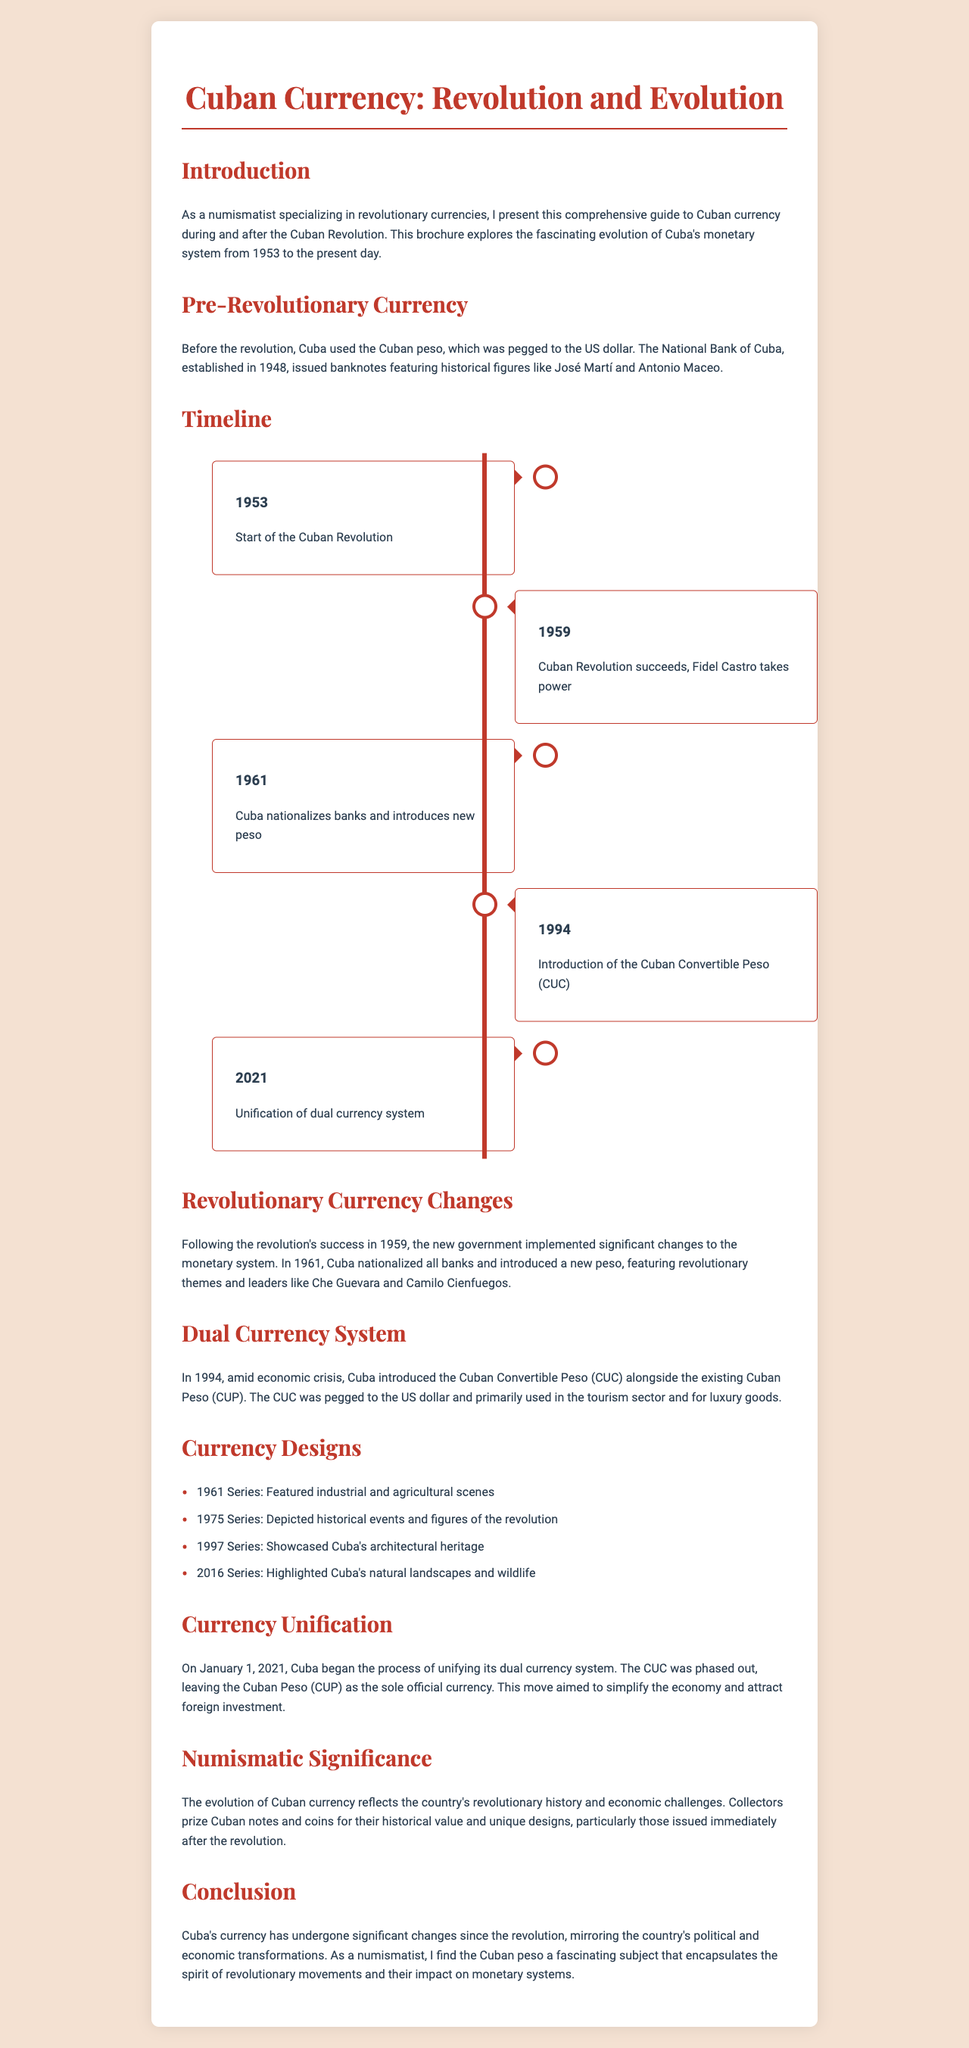What year did the Cuban Revolution begin? The brochure states that the Cuban Revolution started in 1953.
Answer: 1953 What is the main currency introduced in 1961? The document mentions that in 1961, Cuba nationalized banks and introduced a new peso.
Answer: New peso What significant event occurred in 2021 regarding Cuban currency? The brochure highlights that in 2021, Cuba unified its dual currency system.
Answer: Currency unification Which notable figure is featured on banknotes from the pre-revolutionary period? According to the document, pre-revolutionary banknotes featured historical figures like José Martí.
Answer: José Martí What was the purpose of the Cuban Convertible Peso introduced in 1994? The brochure explains that the CUC was primarily used in the tourism sector and for luxury goods.
Answer: Tourism sector How many series of currency designs are listed in the document? The brochure enumerates four series of currency designs.
Answer: Four What theme was featured in the currency designs introduced after the revolution? The document states that the new peso featured revolutionary themes and leaders.
Answer: Revolutionary themes In what year did Fidel Castro take power in Cuba? The timeline states that Fidel Castro took power in 1959 after the revolution succeeded.
Answer: 1959 What was the role of the National Bank of Cuba before the revolution? The document indicates that the National Bank of Cuba issued banknotes prior to the revolution.
Answer: Issued banknotes 